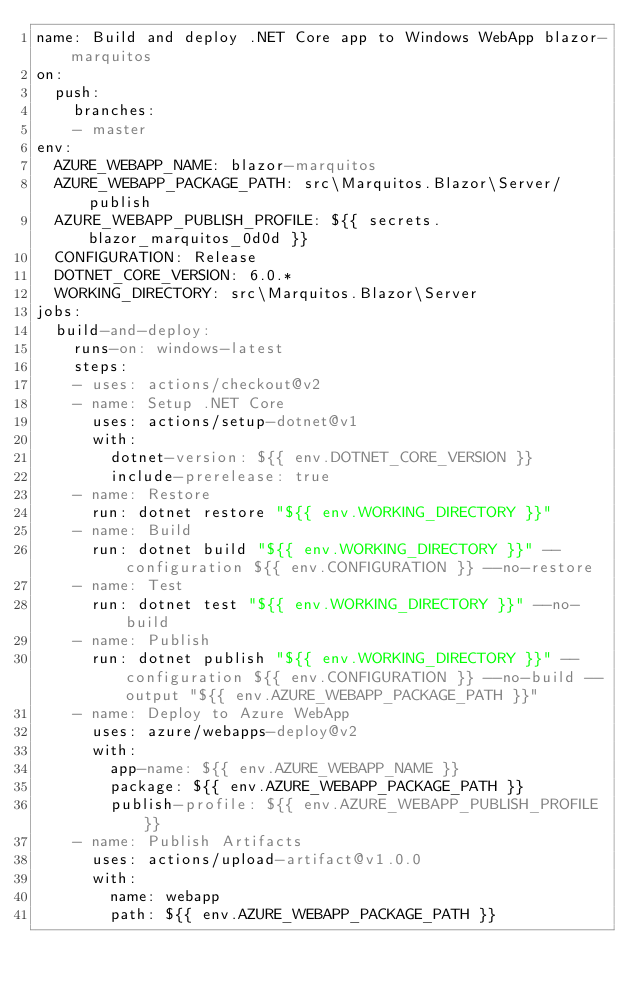Convert code to text. <code><loc_0><loc_0><loc_500><loc_500><_YAML_>name: Build and deploy .NET Core app to Windows WebApp blazor-marquitos
on:
  push:
    branches:
    - master
env:
  AZURE_WEBAPP_NAME: blazor-marquitos
  AZURE_WEBAPP_PACKAGE_PATH: src\Marquitos.Blazor\Server/publish
  AZURE_WEBAPP_PUBLISH_PROFILE: ${{ secrets.blazor_marquitos_0d0d }}
  CONFIGURATION: Release
  DOTNET_CORE_VERSION: 6.0.*
  WORKING_DIRECTORY: src\Marquitos.Blazor\Server
jobs:
  build-and-deploy:
    runs-on: windows-latest
    steps:
    - uses: actions/checkout@v2
    - name: Setup .NET Core
      uses: actions/setup-dotnet@v1
      with:
        dotnet-version: ${{ env.DOTNET_CORE_VERSION }}
        include-prerelease: true
    - name: Restore
      run: dotnet restore "${{ env.WORKING_DIRECTORY }}"
    - name: Build
      run: dotnet build "${{ env.WORKING_DIRECTORY }}" --configuration ${{ env.CONFIGURATION }} --no-restore
    - name: Test
      run: dotnet test "${{ env.WORKING_DIRECTORY }}" --no-build
    - name: Publish
      run: dotnet publish "${{ env.WORKING_DIRECTORY }}" --configuration ${{ env.CONFIGURATION }} --no-build --output "${{ env.AZURE_WEBAPP_PACKAGE_PATH }}"
    - name: Deploy to Azure WebApp
      uses: azure/webapps-deploy@v2
      with:
        app-name: ${{ env.AZURE_WEBAPP_NAME }}
        package: ${{ env.AZURE_WEBAPP_PACKAGE_PATH }}
        publish-profile: ${{ env.AZURE_WEBAPP_PUBLISH_PROFILE }}
    - name: Publish Artifacts
      uses: actions/upload-artifact@v1.0.0
      with:
        name: webapp
        path: ${{ env.AZURE_WEBAPP_PACKAGE_PATH }}
</code> 